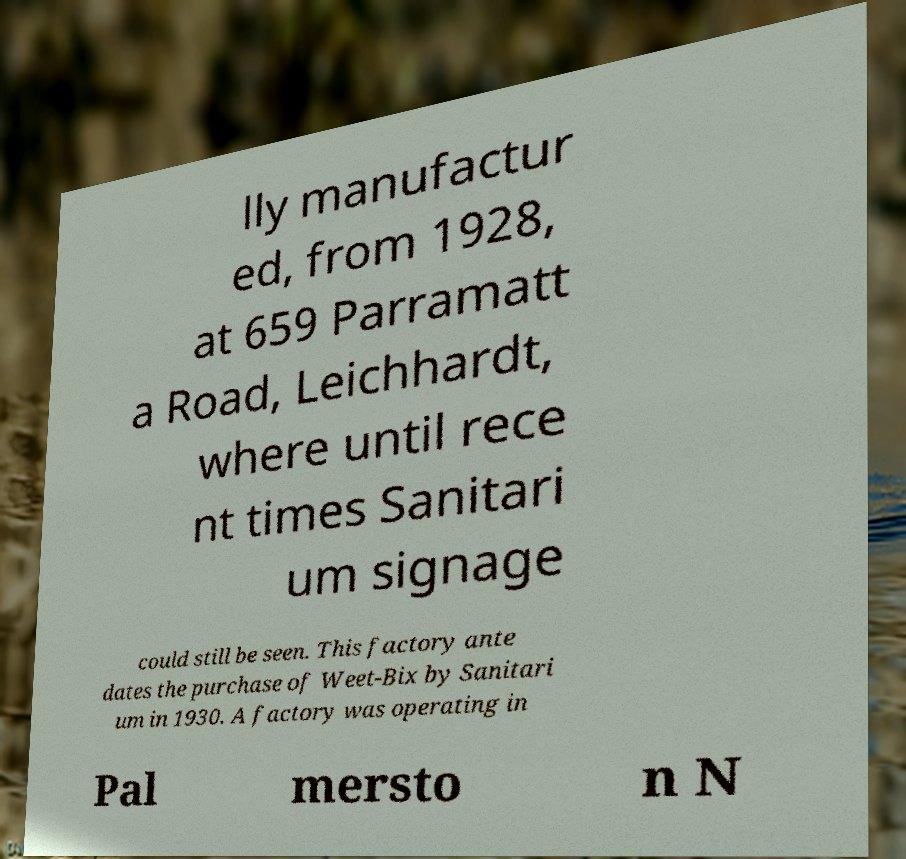Could you extract and type out the text from this image? lly manufactur ed, from 1928, at 659 Parramatt a Road, Leichhardt, where until rece nt times Sanitari um signage could still be seen. This factory ante dates the purchase of Weet-Bix by Sanitari um in 1930. A factory was operating in Pal mersto n N 